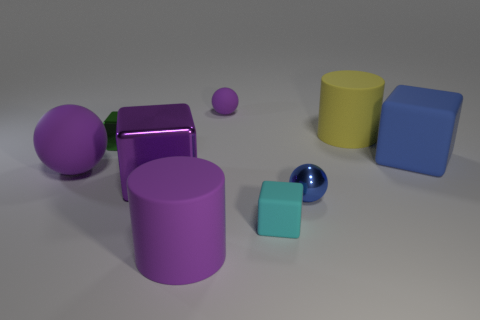There is a tiny thing that is to the left of the large purple shiny thing; does it have the same color as the large sphere? no 